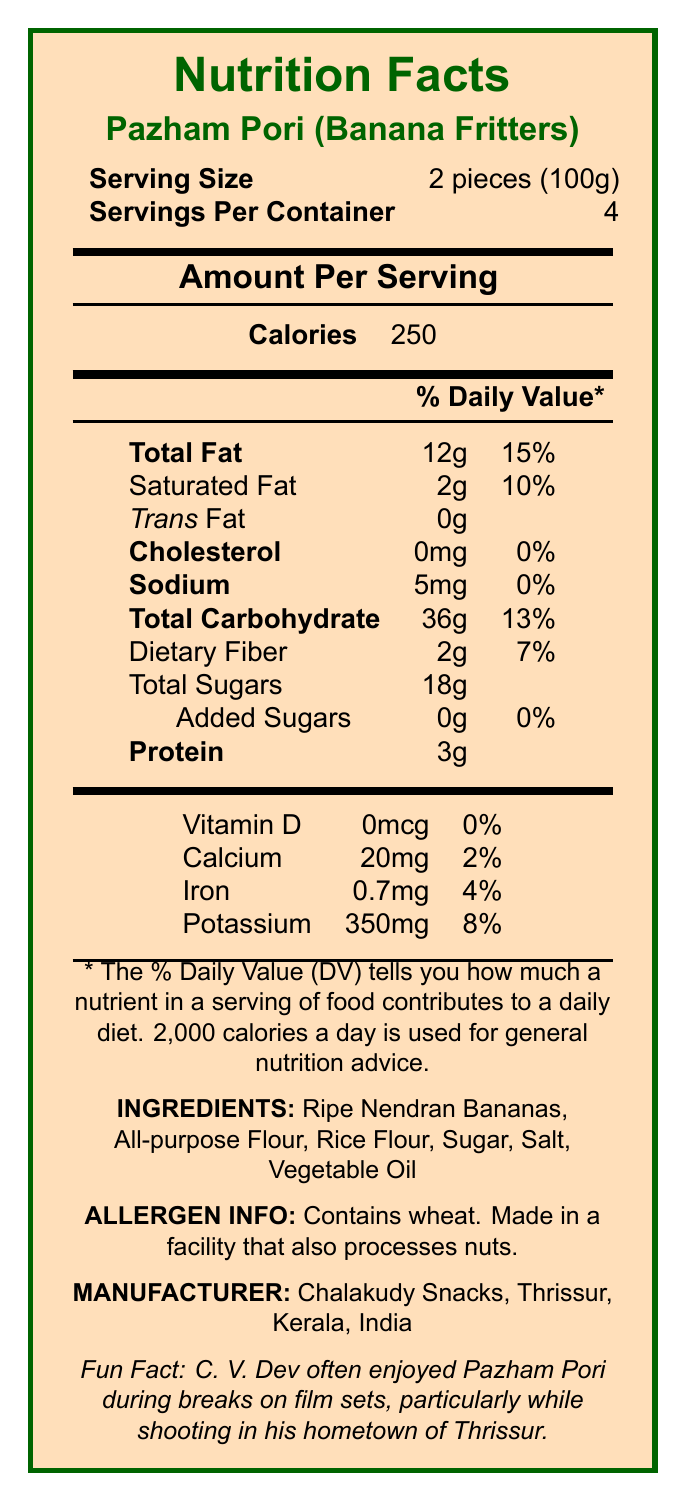what is the serving size of Pazham Pori? The serving size section of the document states that the serving size is 2 pieces (100g).
Answer: 2 pieces (100g) how many calories does one serving of Pazham Pori contain? The calories section of the document states that there are 250 calories per serving.
Answer: 250 calories what is the total fat content per serving? The total fat section indicates that one serving contains 12g of total fat.
Answer: 12g what is the amount of sodium per serving of Pazham Pori? According to the sodium section, there are 5mg of sodium per serving.
Answer: 5mg which ingredient is the primary component of Pazham Pori? The ingredients list starts with Ripe Nendran Bananas, indicating it is the primary component.
Answer: Ripe Nendran Bananas which nutrient has the highest daily value percentage? A. Saturated Fat B. Dietary Fiber C. Potassium D. Total Fat The total fat section shows a daily value of 15%, which is higher than any other nutrient's daily value percentage listed.
Answer: D. Total Fat how many servings are there per container of Pazham Pori? A. 2 B. 3 C. 4 D. 5 The servings per container section states there are 4 servings per container.
Answer: C. 4 is there any added sugar in Pazham Pori? The total sugars section specifies that there are 0g of added sugars per serving.
Answer: No does Pazham Pori contain any cholesterol? The cholesterol section states that there is 0mg of cholesterol, indicating it contains none.
Answer: No please summarize the main nutritional content of Pazham Pori. This summary combines the main nutritional aspects provided in the document, the ingredients, allergen information, and manufacturer details to give an overall understanding of Pazham Pori's nutritional profile.
Answer: Pazham Pori (Banana Fritters) serves 4 per container, with a serving size of 2 pieces (100g) containing 250 calories, 12g total fat (15% DV), 2g saturated fat (10% DV), 0g trans fat, 0mg cholesterol, 5mg sodium (0% DV), 36g total carbohydrate (13% DV), 2g dietary fiber (7% DV), 18g total sugars, including 0g added sugars, and 3g protein. It also contains 0mcg vitamin D (0% DV), 20mg calcium (2% DV), 0.7mg iron (4% DV), and 350mg potassium (8% DV). The ingredients are Ripe Nendran Bananas, All-purpose Flour, Rice Flour, Sugar, Salt, and Vegetable Oil. It contains wheat and is made in a facility that processes nuts. Manufactured by Chalakudy Snacks, Thrissur, Kerala, India. where is Chalakudy Snacks located? The manufacturer section lists the address as Thrissur, Kerala, India.
Answer: Thrissur, Kerala, India how much iron is present per serving of Pazham Pori? The iron section in the document states that there is 0.7mg of iron per serving.
Answer: 0.7mg does the document state the price of Pazham Pori? The document does not provide any details regarding the price of Pazham Pori.
Answer: Not enough information 